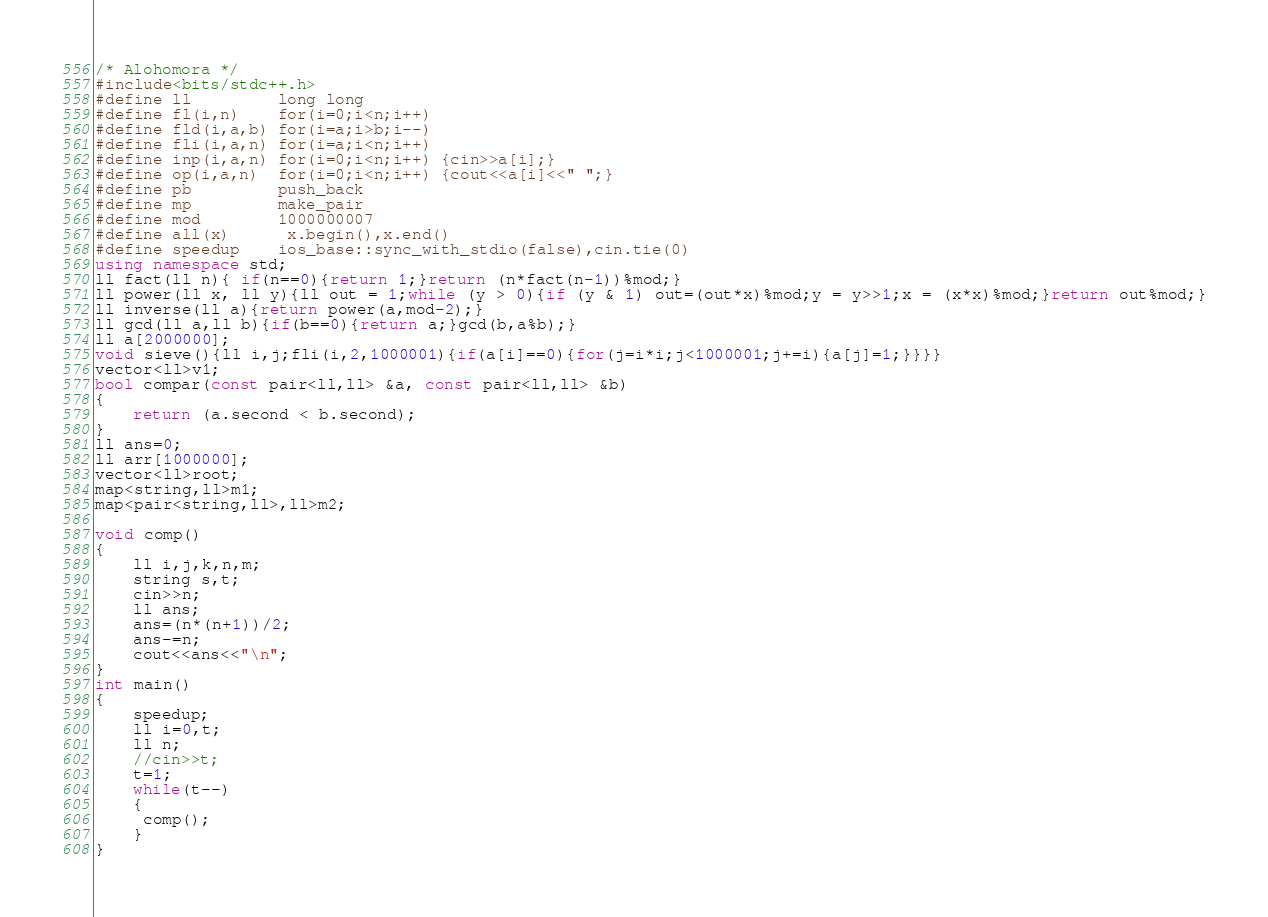<code> <loc_0><loc_0><loc_500><loc_500><_C++_>/* Alohomora */
#include<bits/stdc++.h>
#define ll         long long
#define fl(i,n)    for(i=0;i<n;i++)
#define fld(i,a,b) for(i=a;i>b;i--)
#define fli(i,a,n) for(i=a;i<n;i++)
#define inp(i,a,n) for(i=0;i<n;i++) {cin>>a[i];}
#define op(i,a,n)  for(i=0;i<n;i++) {cout<<a[i]<<" ";}
#define pb         push_back
#define mp         make_pair
#define mod        1000000007 
#define all(x) 	   x.begin(),x.end()	
#define speedup    ios_base::sync_with_stdio(false),cin.tie(0)
using namespace std;
ll fact(ll n){ if(n==0){return 1;}return (n*fact(n-1))%mod;}
ll power(ll x, ll y){ll out = 1;while (y > 0){if (y & 1) out=(out*x)%mod;y = y>>1;x = (x*x)%mod;}return out%mod;}
ll inverse(ll a){return power(a,mod-2);}
ll gcd(ll a,ll b){if(b==0){return a;}gcd(b,a%b);}
ll a[2000000];
void sieve(){ll i,j;fli(i,2,1000001){if(a[i]==0){for(j=i*i;j<1000001;j+=i){a[j]=1;}}}}
vector<ll>v1;
bool compar(const pair<ll,ll> &a, const pair<ll,ll> &b) 
{ 
    return (a.second < b.second);
} 
ll ans=0;
ll arr[1000000];
vector<ll>root;
map<string,ll>m1;
map<pair<string,ll>,ll>m2;

void comp()
{
	ll i,j,k,n,m;
	string s,t;
	cin>>n;
	ll ans;
	ans=(n*(n+1))/2;
	ans-=n;
	cout<<ans<<"\n";
} 
int main()
{
	speedup;
	ll i=0,t;
	ll n;
	//cin>>t;
	t=1;
	while(t--)
	{
	 comp();
	}
}</code> 